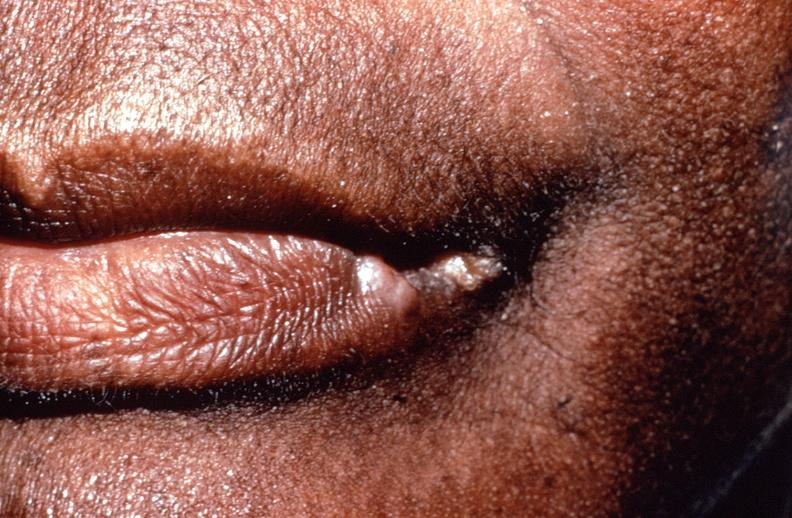s gastrointestinal present?
Answer the question using a single word or phrase. Yes 